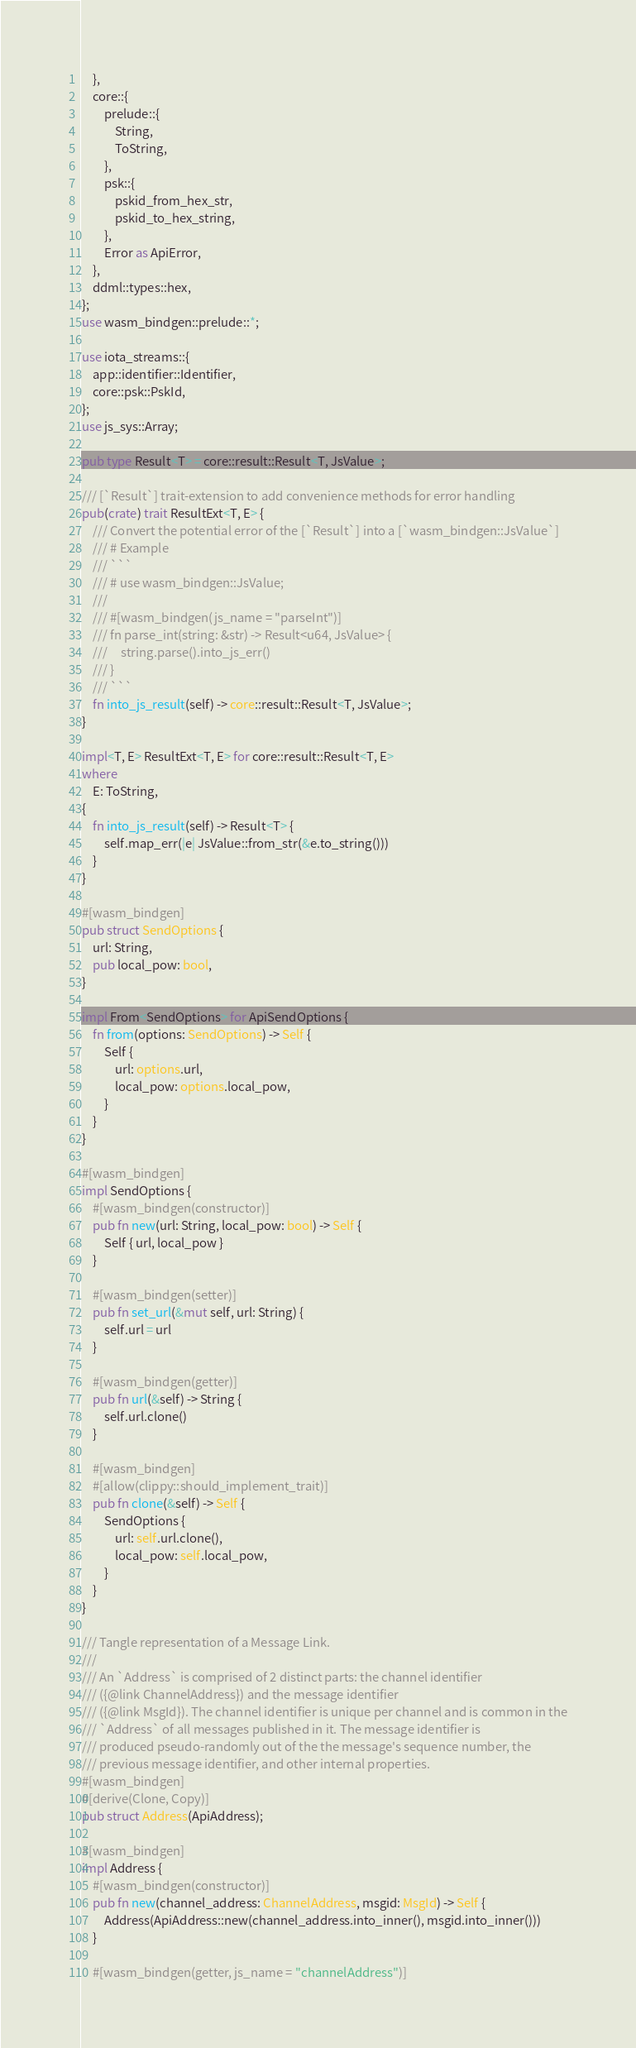Convert code to text. <code><loc_0><loc_0><loc_500><loc_500><_Rust_>    },
    core::{
        prelude::{
            String,
            ToString,
        },
        psk::{
            pskid_from_hex_str,
            pskid_to_hex_string,
        },
        Error as ApiError,
    },
    ddml::types::hex,
};
use wasm_bindgen::prelude::*;

use iota_streams::{
    app::identifier::Identifier,
    core::psk::PskId,
};
use js_sys::Array;

pub type Result<T> = core::result::Result<T, JsValue>;

/// [`Result`] trait-extension to add convenience methods for error handling
pub(crate) trait ResultExt<T, E> {
    /// Convert the potential error of the [`Result`] into a [`wasm_bindgen::JsValue`]
    /// # Example
    /// ```
    /// # use wasm_bindgen::JsValue;
    ///
    /// #[wasm_bindgen(js_name = "parseInt")]
    /// fn parse_int(string: &str) -> Result<u64, JsValue> {
    ///     string.parse().into_js_err()
    /// }
    /// ```
    fn into_js_result(self) -> core::result::Result<T, JsValue>;
}

impl<T, E> ResultExt<T, E> for core::result::Result<T, E>
where
    E: ToString,
{
    fn into_js_result(self) -> Result<T> {
        self.map_err(|e| JsValue::from_str(&e.to_string()))
    }
}

#[wasm_bindgen]
pub struct SendOptions {
    url: String,
    pub local_pow: bool,
}

impl From<SendOptions> for ApiSendOptions {
    fn from(options: SendOptions) -> Self {
        Self {
            url: options.url,
            local_pow: options.local_pow,
        }
    }
}

#[wasm_bindgen]
impl SendOptions {
    #[wasm_bindgen(constructor)]
    pub fn new(url: String, local_pow: bool) -> Self {
        Self { url, local_pow }
    }

    #[wasm_bindgen(setter)]
    pub fn set_url(&mut self, url: String) {
        self.url = url
    }

    #[wasm_bindgen(getter)]
    pub fn url(&self) -> String {
        self.url.clone()
    }

    #[wasm_bindgen]
    #[allow(clippy::should_implement_trait)]
    pub fn clone(&self) -> Self {
        SendOptions {
            url: self.url.clone(),
            local_pow: self.local_pow,
        }
    }
}

/// Tangle representation of a Message Link.
///
/// An `Address` is comprised of 2 distinct parts: the channel identifier
/// ({@link ChannelAddress}) and the message identifier
/// ({@link MsgId}). The channel identifier is unique per channel and is common in the
/// `Address` of all messages published in it. The message identifier is
/// produced pseudo-randomly out of the the message's sequence number, the
/// previous message identifier, and other internal properties.
#[wasm_bindgen]
#[derive(Clone, Copy)]
pub struct Address(ApiAddress);

#[wasm_bindgen]
impl Address {
    #[wasm_bindgen(constructor)]
    pub fn new(channel_address: ChannelAddress, msgid: MsgId) -> Self {
        Address(ApiAddress::new(channel_address.into_inner(), msgid.into_inner()))
    }

    #[wasm_bindgen(getter, js_name = "channelAddress")]</code> 